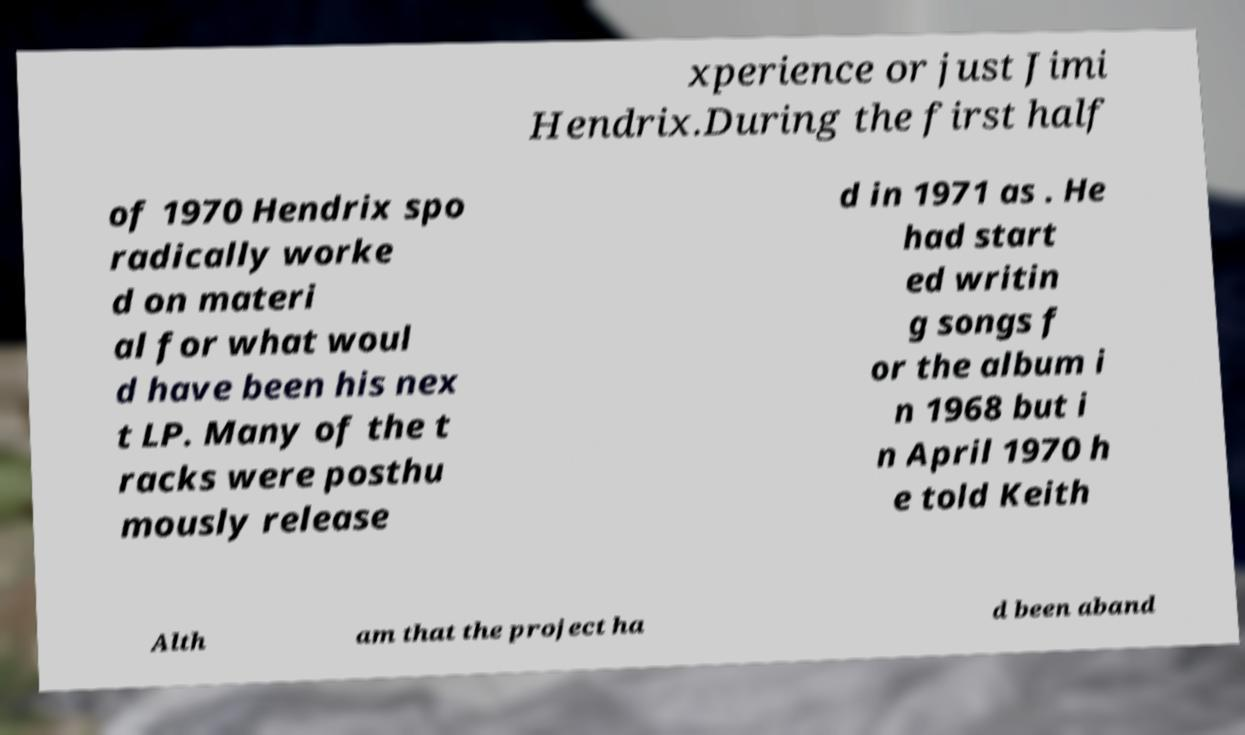Could you assist in decoding the text presented in this image and type it out clearly? xperience or just Jimi Hendrix.During the first half of 1970 Hendrix spo radically worke d on materi al for what woul d have been his nex t LP. Many of the t racks were posthu mously release d in 1971 as . He had start ed writin g songs f or the album i n 1968 but i n April 1970 h e told Keith Alth am that the project ha d been aband 